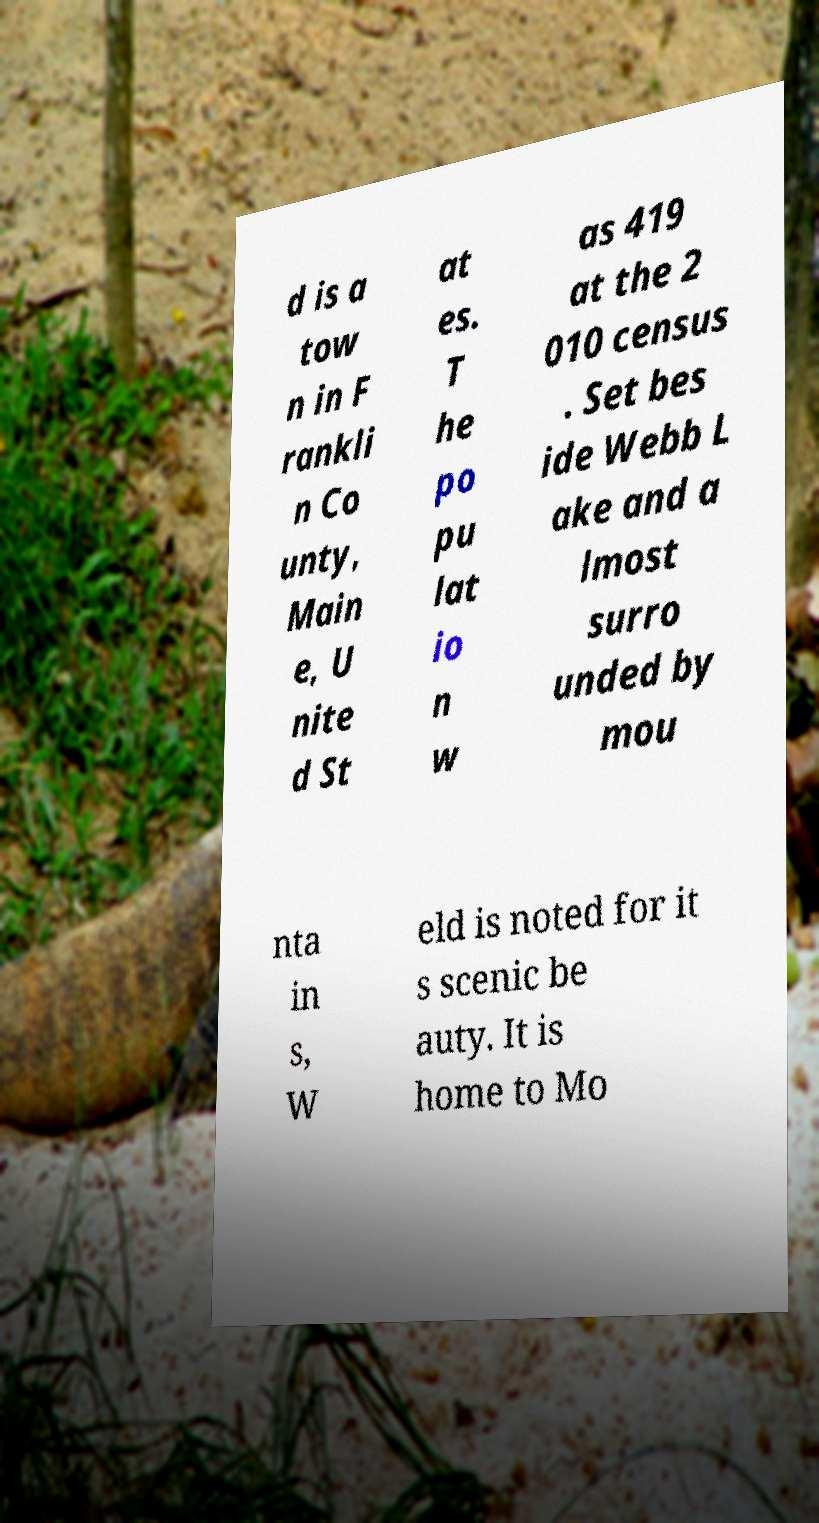Could you assist in decoding the text presented in this image and type it out clearly? d is a tow n in F rankli n Co unty, Main e, U nite d St at es. T he po pu lat io n w as 419 at the 2 010 census . Set bes ide Webb L ake and a lmost surro unded by mou nta in s, W eld is noted for it s scenic be auty. It is home to Mo 